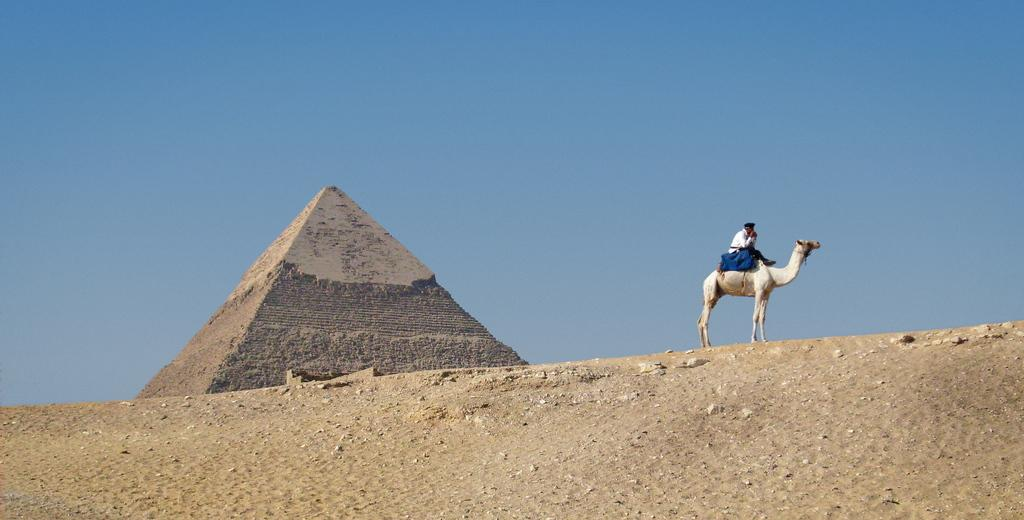What is the main structure featured in the image? There is a pyramid in the image. What activity is taking place in the image? A person is riding a camel in the image. What can be seen in the background of the image? There is sky visible in the background of the image. What type of square object can be seen in the image? There is no square object present in the image. Can you tell me how many beetles are crawling on the pyramid in the image? There are no beetles present in the image; it features a person riding a camel near a pyramid. 